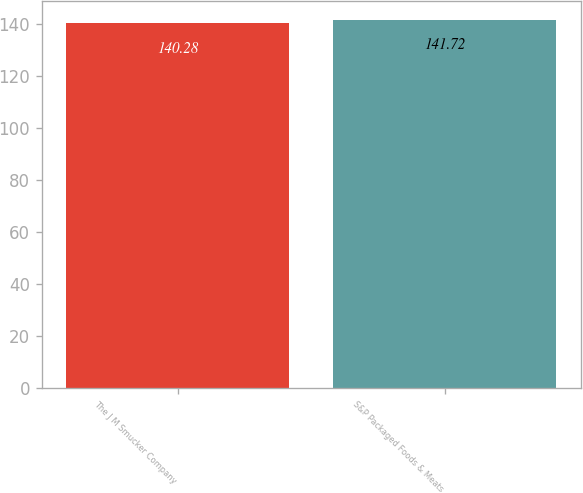<chart> <loc_0><loc_0><loc_500><loc_500><bar_chart><fcel>The J M Smucker Company<fcel>S&P Packaged Foods & Meats<nl><fcel>140.28<fcel>141.72<nl></chart> 